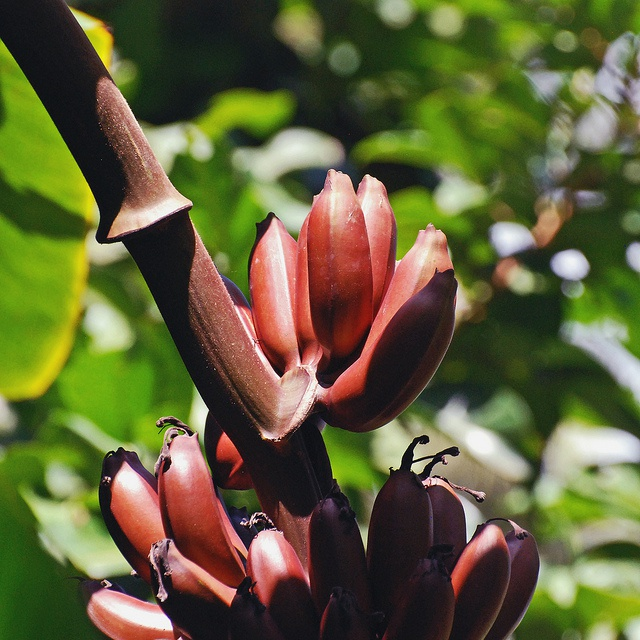Describe the objects in this image and their specific colors. I can see banana in black, maroon, salmon, and lightpink tones, banana in black, maroon, gray, and tan tones, and banana in black, lightpink, maroon, and lightgray tones in this image. 